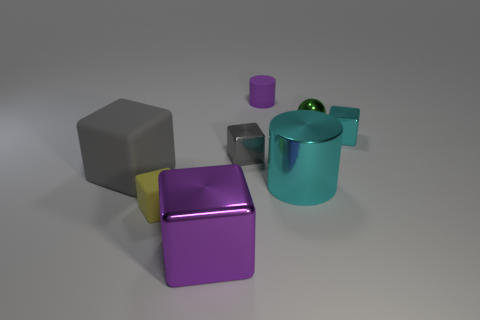Subtract 2 blocks. How many blocks are left? 3 Subtract all cyan cubes. How many cubes are left? 4 Subtract all tiny cyan shiny cubes. How many cubes are left? 4 Subtract all red cubes. Subtract all red balls. How many cubes are left? 5 Add 1 small cylinders. How many objects exist? 9 Subtract all cubes. How many objects are left? 3 Add 5 purple rubber things. How many purple rubber things exist? 6 Subtract 1 gray blocks. How many objects are left? 7 Subtract all tiny rubber cylinders. Subtract all small cyan shiny objects. How many objects are left? 6 Add 3 tiny cylinders. How many tiny cylinders are left? 4 